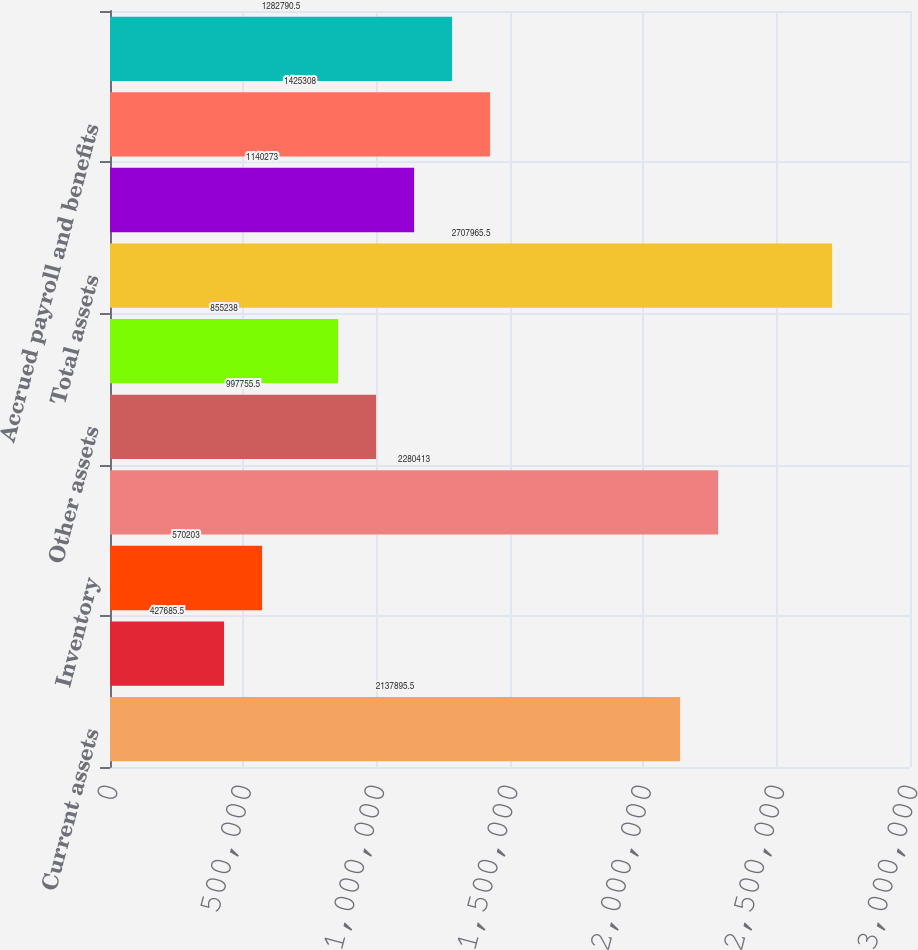<chart> <loc_0><loc_0><loc_500><loc_500><bar_chart><fcel>Current assets<fcel>and 208 as of December 31 2012<fcel>Inventory<fcel>Total current assets Leasehold<fcel>Other assets<fcel>Goodwill<fcel>Total assets<fcel>Accounts payable<fcel>Accrued payroll and benefits<fcel>Accrued liabilities<nl><fcel>2.1379e+06<fcel>427686<fcel>570203<fcel>2.28041e+06<fcel>997756<fcel>855238<fcel>2.70797e+06<fcel>1.14027e+06<fcel>1.42531e+06<fcel>1.28279e+06<nl></chart> 